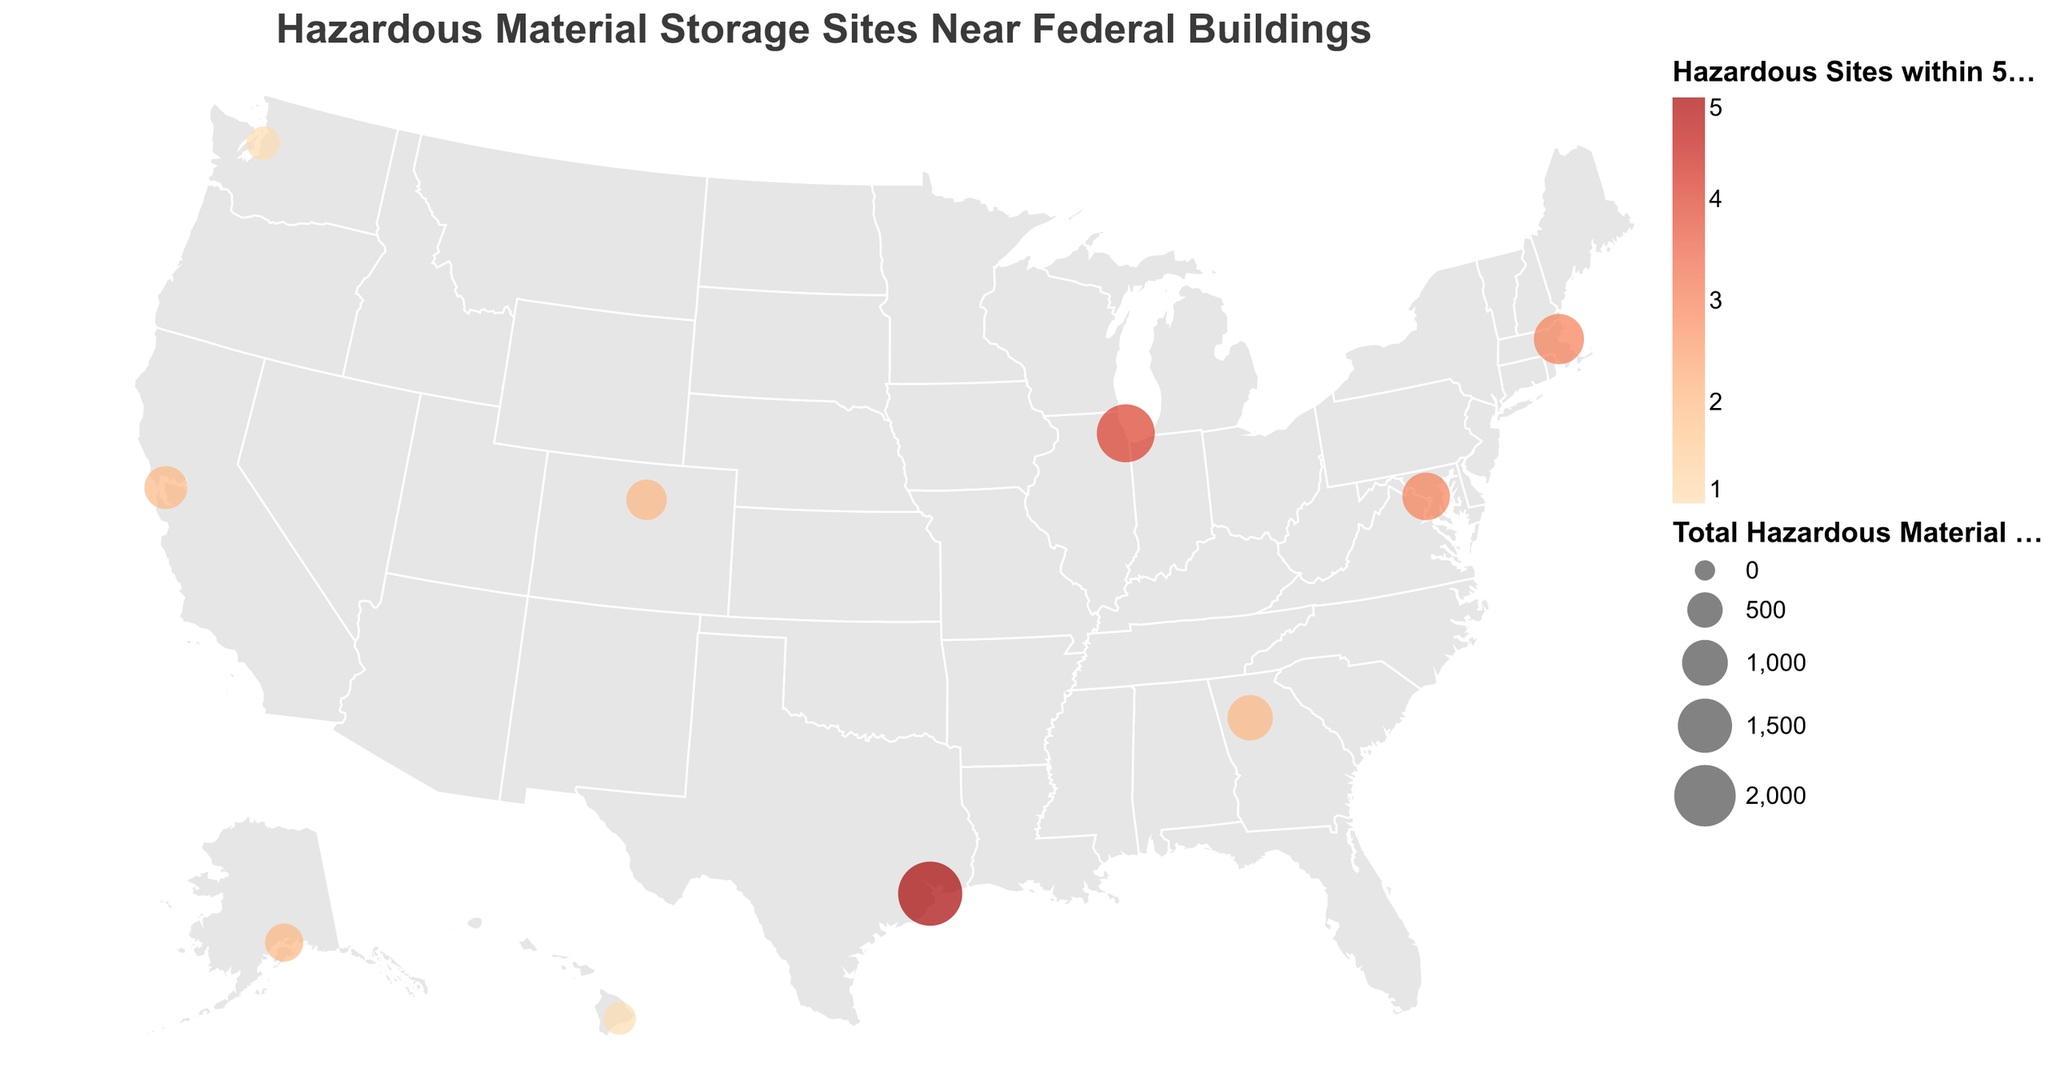What regions have the highest and lowest total hazardous material volume? To determine this, look at the size of the circles, as they represent the total hazardous material volume. The largest circle is in the Southwest at NASA Johnson Space Center, indicating the highest volume, while the smallest circle is in the Northwest at NOAA Western Regional Center, indicating the lowest volume.
Answer: Southwest has the highest and Northwest has the lowest Which region has the most hazardous sites within 5km? Look at the color legend and the circles' color intensities. The circle with the darkest color is in the Southwest at NASA Johnson Space Center, indicating the highest number of sites.
Answer: Southwest How many regions have exactly two hazardous sites within 5km? Check the color intensity of circles indicating two hazardous sites on the map. There are four regions: Southeast, West, Rocky Mountains, and Alaska.
Answer: 4 What is the combined total hazardous material volume for the regions with exactly three hazardous sites within 5km? Identify the regions with three hazardous sites (Northeast and Mid-Atlantic) and sum their total volumes (1250 + 1100).
Answer: 2350 tons How does the total hazardous material volume at NASA Johnson Space Center compare to that at FBI Chicago Field Office? Compare the size of the circles for each location. The Southwest at NASA Johnson Space Center has a larger circle (2200 tons) compared to the Midwest at FBI Chicago Field Office (1750 tons).
Answer: NASA Johnson Space Center has a higher volume What is the average number of hazardous sites within 5km across all federal buildings? Sum the number of hazardous sites within 5km for all regions (3 + 2 + 4 + 5 + 2 + 1 + 3 + 2 + 1 + 2 = 25) and divide by the number of regions (10).
Answer: 2.5 Are there any regions with the same total hazardous material volume and number of hazardous sites within 5km? Compare the total hazardous material volumes and hazardous site counts for each region. None of the regions share the same total volume and site count.
Answer: No What region has the largest discrepancy between its hazardous sites within 5km and total hazardous material volume? Calculate the differences between the number of hazardous sites and total volume for each region. The region with the largest discrepancy is the Southwest, with 5 sites and 2200 tons.
Answer: Southwest How many regions have only one hazardous site within 5km? Check the color intensity of the circles for one hazardous site. Only Northwest and Hawaii regions have one hazardous site each.
Answer: 2 